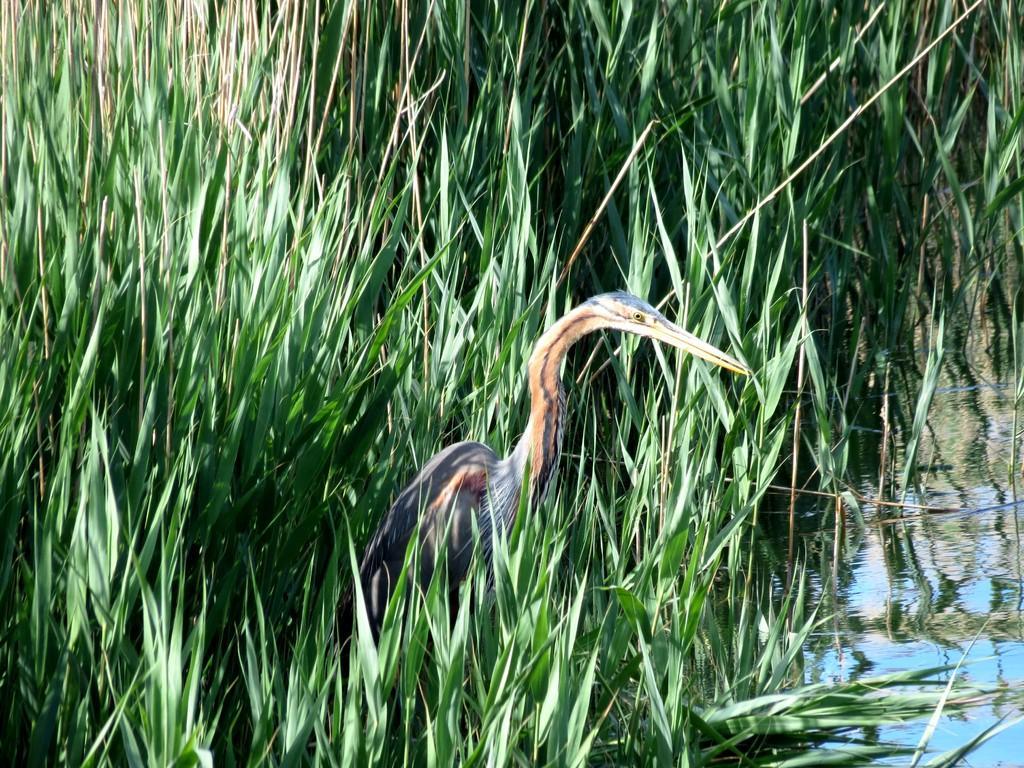Describe this image in one or two sentences. In the foreground I can see a bird on the grass and water. This image is taken may be near the lake during a day. 